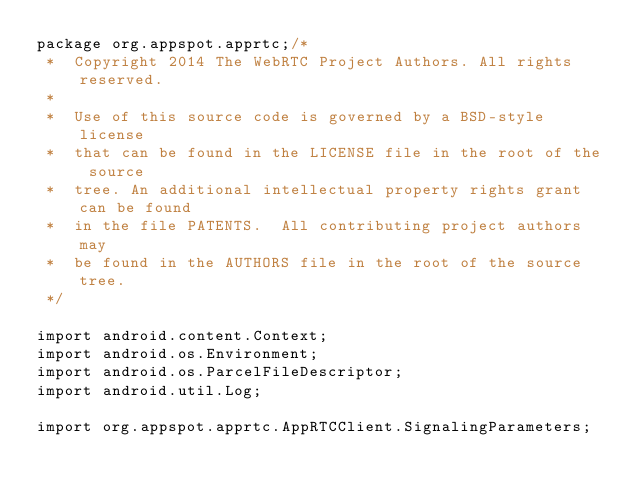<code> <loc_0><loc_0><loc_500><loc_500><_Java_>package org.appspot.apprtc;/*
 *  Copyright 2014 The WebRTC Project Authors. All rights reserved.
 *
 *  Use of this source code is governed by a BSD-style license
 *  that can be found in the LICENSE file in the root of the source
 *  tree. An additional intellectual property rights grant can be found
 *  in the file PATENTS.  All contributing project authors may
 *  be found in the AUTHORS file in the root of the source tree.
 */

import android.content.Context;
import android.os.Environment;
import android.os.ParcelFileDescriptor;
import android.util.Log;

import org.appspot.apprtc.AppRTCClient.SignalingParameters;</code> 